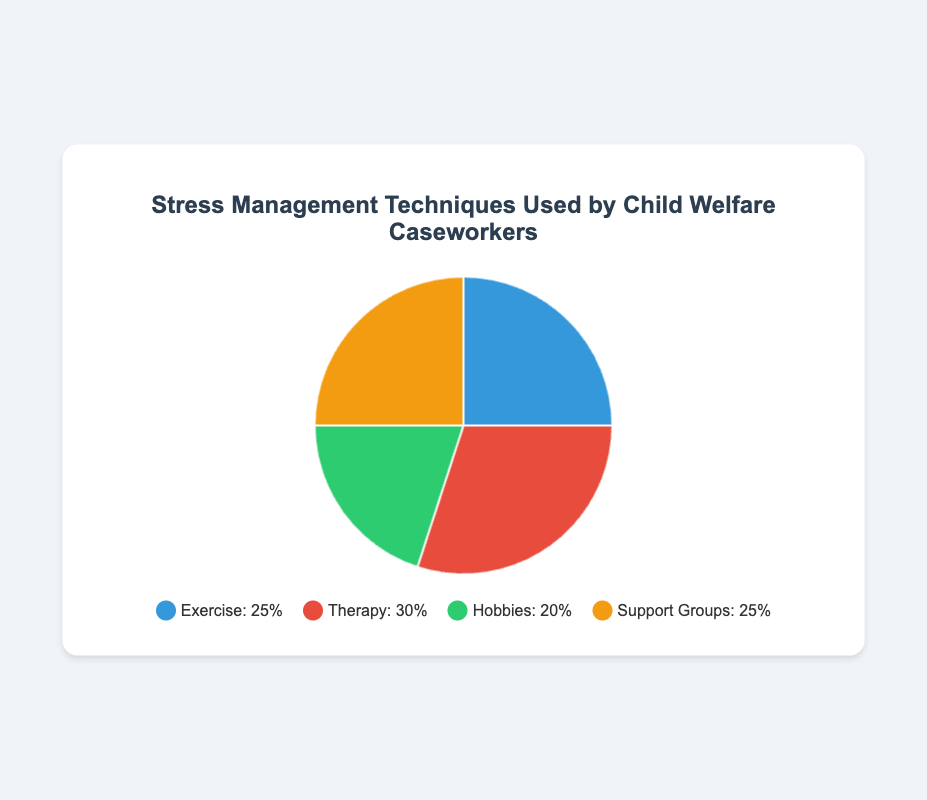What is the most common stress management technique used by caseworkers? The most common technique is identified by finding the segment with the highest percentage. Therapy has the highest percentage at 30%.
Answer: Therapy Which stress management technique has the same percentage of use as Support Groups? By referring to the percentage values, Exercise and Support Groups both have a percentage of 25%.
Answer: Exercise What is the total percentage of caseworkers using Exercise and Therapy combined? Adding the percentages for Exercise and Therapy: 25% (Exercise) + 30% (Therapy) = 55%
Answer: 55% How much lower is the percentage of caseworkers using Hobbies compared to Therapy? Subtract the percentage of Hobbies from Therapy: 30% (Therapy) - 20% (Hobbies) = 10%
Answer: 10% Which stress management technique is least used, and by how much is it less than the most used technique? The technique with the lowest percentage is Hobbies at 20%. The difference between the highest (Therapy at 30%) and lowest is: 30% - 20% = 10%
Answer: Hobbies, 10% What stress management techniques have equal proportions and what proportion of the caseworkers use these techniques? Exercise and Support Groups both have a 25% share.
Answer: Exercise and Support Groups, 25% If we combine the percentages for Hobbies and Support Groups, what total percentage do they represent? Adding the percentages for Hobbies and Support Groups: 20% (Hobbies) + 25% (Support Groups) = 45%
Answer: 45% What color represents the Hobbies segment in the pie chart? The visual attribute (color) for Hobbies is described as green.
Answer: Green Out of all the stress management techniques compared, which one is least favored, and can you list two other techniques that are more favored based on the given data? The least favored technique is Hobbies at 20%. The two other techniques with higher percentages are Therapy at 30% and both Exercise and Support Groups at 25%.
Answer: Hobbies, Therapy and Support Groups If you want to encourage the use of the least popular stress management technique to bring its usage up to 25%, how many percentage points do you need to increase? Current use of Hobbies is 20%, and the goal is 25%. The increase needed is 25% - 20% = 5%.
Answer: 5% 